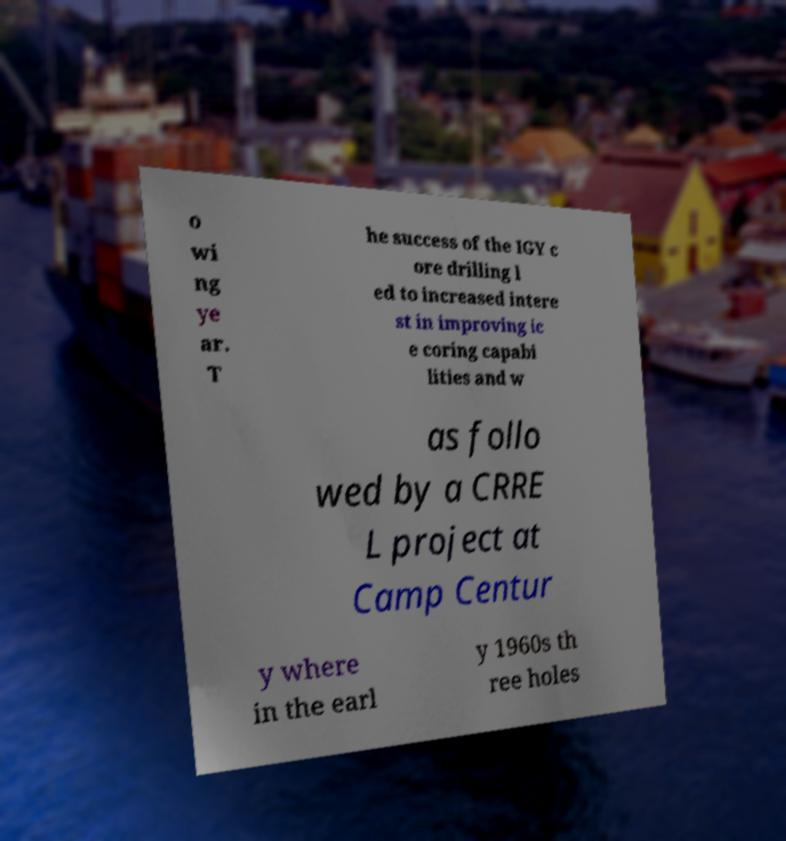What messages or text are displayed in this image? I need them in a readable, typed format. o wi ng ye ar. T he success of the IGY c ore drilling l ed to increased intere st in improving ic e coring capabi lities and w as follo wed by a CRRE L project at Camp Centur y where in the earl y 1960s th ree holes 